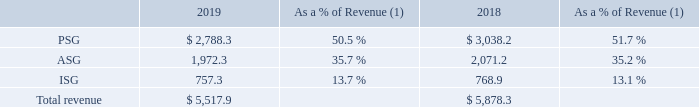Revenue
Revenue was $5,517.9 million and $5,878.3 million for 2019 and 2018, respectively. The decrease of $360.4 million, or 6.1% was primarily attributable to an 8.2%, 4.8% and 1.5% decrease in revenue in PSG, ASG and ISG, respectively, which is further explained below. Revenue by reportable segment for each were as follows (dollars in millions):
(1) Certain of the amounts may not total due to rounding of individual amounts.
Revenue from PSG
Revenue from PSG decreased by $249.9 million, or approximately 8%, which was due to a combination of a decrease in volume of products sold and a competitive pricing environment. The revenue in our Protection and Signal Division, Integrated Circuits Division, and High Power Division, decreased by $106.5 million, $96.6 million and $91.5 million, respectively. This was partially offset by an increase in revenue of $30.1 million and $15.0 million from our Foundry Services and Power Mosfet Division, respectively.
Revenue from ASG
Revenue from ASG decreased by $98.9 million, or approximately 5%, which was also due to a combination of a decrease in volume of products sold and a competitive pricing environment. The revenue in our Industrial and Offline Power Division and our Signal Processing, Wireless and Medical Division, decreased by $100.5 million and $56.4 million, respectively. This was partially offset by $84.8 million of revenue from Quantenna, which was acquired during 2019.
Revenue from ISG
Revenue from ISG decreased by $11.6 million, or 1.5%, which was due to a decrease in our Industrial Sensing Division revenue of $20.8 million, primarily due to decreased demand, which was partially offset by an increase in revenue in other divisions.
How much was Revenue for 2019 and 2018 respectively? $5,517.9 million, $5,878.3 million. What led to the decrease in overall Revenue between 2018 and 2019? Primarily attributable to an 8.2%, 4.8% and 1.5% decrease in revenue in psg, asg and isg, respectively. What led to the decrease in Revenue from PSG? Due to a combination of a decrease in volume of products sold and a competitive pricing environment. What is the change in revenue from PSG from 2018 to 2019?
Answer scale should be: million. 2,788.3-3,038.2
Answer: -249.9. What is the change in revenues from ASG from 2018 to 2019?
Answer scale should be: million. 1,972.3-2,071.2
Answer: -98.9. What is the average revenue from PSG for 2018 to 2019?
Answer scale should be: million. (2,788.3+3,038.2) / 2
Answer: 2913.25. 